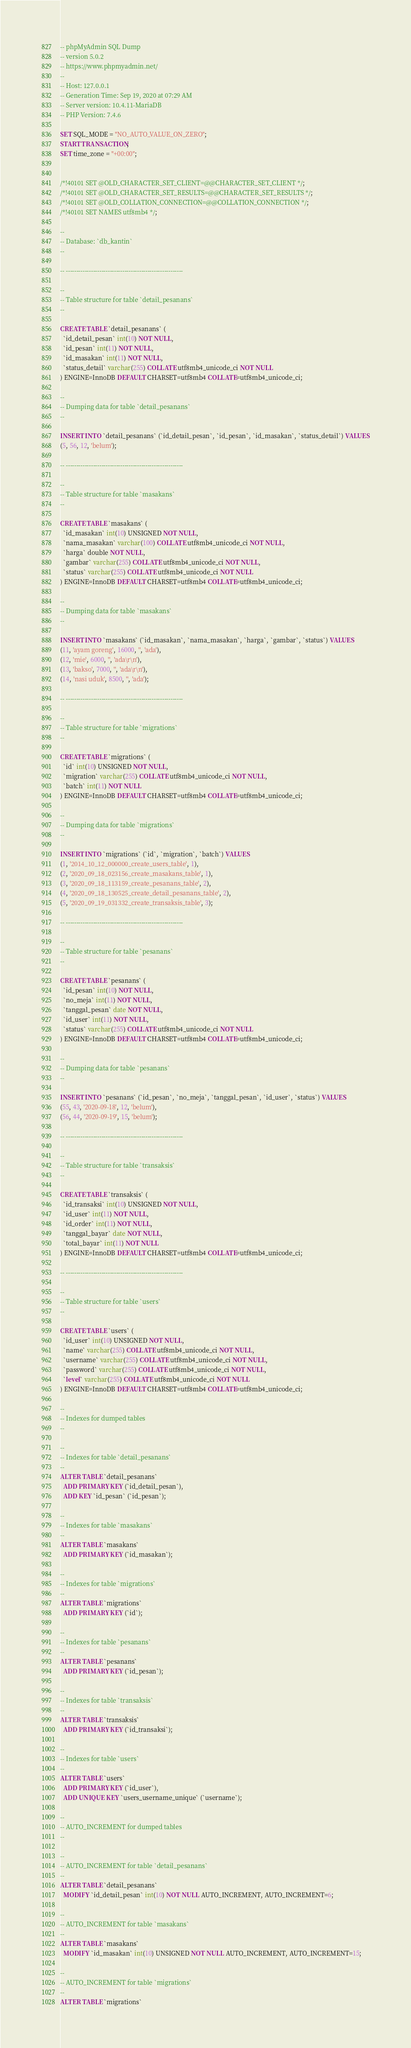Convert code to text. <code><loc_0><loc_0><loc_500><loc_500><_SQL_>-- phpMyAdmin SQL Dump
-- version 5.0.2
-- https://www.phpmyadmin.net/
--
-- Host: 127.0.0.1
-- Generation Time: Sep 19, 2020 at 07:29 AM
-- Server version: 10.4.11-MariaDB
-- PHP Version: 7.4.6

SET SQL_MODE = "NO_AUTO_VALUE_ON_ZERO";
START TRANSACTION;
SET time_zone = "+00:00";


/*!40101 SET @OLD_CHARACTER_SET_CLIENT=@@CHARACTER_SET_CLIENT */;
/*!40101 SET @OLD_CHARACTER_SET_RESULTS=@@CHARACTER_SET_RESULTS */;
/*!40101 SET @OLD_COLLATION_CONNECTION=@@COLLATION_CONNECTION */;
/*!40101 SET NAMES utf8mb4 */;

--
-- Database: `db_kantin`
--

-- --------------------------------------------------------

--
-- Table structure for table `detail_pesanans`
--

CREATE TABLE `detail_pesanans` (
  `id_detail_pesan` int(10) NOT NULL,
  `id_pesan` int(11) NOT NULL,
  `id_masakan` int(11) NOT NULL,
  `status_detail` varchar(255) COLLATE utf8mb4_unicode_ci NOT NULL
) ENGINE=InnoDB DEFAULT CHARSET=utf8mb4 COLLATE=utf8mb4_unicode_ci;

--
-- Dumping data for table `detail_pesanans`
--

INSERT INTO `detail_pesanans` (`id_detail_pesan`, `id_pesan`, `id_masakan`, `status_detail`) VALUES
(5, 56, 12, 'belum');

-- --------------------------------------------------------

--
-- Table structure for table `masakans`
--

CREATE TABLE `masakans` (
  `id_masakan` int(10) UNSIGNED NOT NULL,
  `nama_masakan` varchar(100) COLLATE utf8mb4_unicode_ci NOT NULL,
  `harga` double NOT NULL,
  `gambar` varchar(255) COLLATE utf8mb4_unicode_ci NOT NULL,
  `status` varchar(255) COLLATE utf8mb4_unicode_ci NOT NULL
) ENGINE=InnoDB DEFAULT CHARSET=utf8mb4 COLLATE=utf8mb4_unicode_ci;

--
-- Dumping data for table `masakans`
--

INSERT INTO `masakans` (`id_masakan`, `nama_masakan`, `harga`, `gambar`, `status`) VALUES
(11, 'ayam goreng', 16000, '', 'ada'),
(12, 'mie', 6000, '', 'ada\r\n'),
(13, 'bakso', 7000, '', 'ada\r\n'),
(14, 'nasi uduk', 8500, '', 'ada');

-- --------------------------------------------------------

--
-- Table structure for table `migrations`
--

CREATE TABLE `migrations` (
  `id` int(10) UNSIGNED NOT NULL,
  `migration` varchar(255) COLLATE utf8mb4_unicode_ci NOT NULL,
  `batch` int(11) NOT NULL
) ENGINE=InnoDB DEFAULT CHARSET=utf8mb4 COLLATE=utf8mb4_unicode_ci;

--
-- Dumping data for table `migrations`
--

INSERT INTO `migrations` (`id`, `migration`, `batch`) VALUES
(1, '2014_10_12_000000_create_users_table', 1),
(2, '2020_09_18_023156_create_masakans_table', 1),
(3, '2020_09_18_113159_create_pesanans_table', 2),
(4, '2020_09_18_130525_create_detail_pesanans_table', 2),
(5, '2020_09_19_031332_create_transaksis_table', 3);

-- --------------------------------------------------------

--
-- Table structure for table `pesanans`
--

CREATE TABLE `pesanans` (
  `id_pesan` int(10) NOT NULL,
  `no_meja` int(11) NOT NULL,
  `tanggal_pesan` date NOT NULL,
  `id_user` int(11) NOT NULL,
  `status` varchar(255) COLLATE utf8mb4_unicode_ci NOT NULL
) ENGINE=InnoDB DEFAULT CHARSET=utf8mb4 COLLATE=utf8mb4_unicode_ci;

--
-- Dumping data for table `pesanans`
--

INSERT INTO `pesanans` (`id_pesan`, `no_meja`, `tanggal_pesan`, `id_user`, `status`) VALUES
(55, 43, '2020-09-18', 12, 'belum'),
(56, 44, '2020-09-19', 15, 'belum');

-- --------------------------------------------------------

--
-- Table structure for table `transaksis`
--

CREATE TABLE `transaksis` (
  `id_transaksi` int(10) UNSIGNED NOT NULL,
  `id_user` int(11) NOT NULL,
  `id_order` int(11) NOT NULL,
  `tanggal_bayar` date NOT NULL,
  `total_bayar` int(11) NOT NULL
) ENGINE=InnoDB DEFAULT CHARSET=utf8mb4 COLLATE=utf8mb4_unicode_ci;

-- --------------------------------------------------------

--
-- Table structure for table `users`
--

CREATE TABLE `users` (
  `id_user` int(10) UNSIGNED NOT NULL,
  `name` varchar(255) COLLATE utf8mb4_unicode_ci NOT NULL,
  `username` varchar(255) COLLATE utf8mb4_unicode_ci NOT NULL,
  `password` varchar(255) COLLATE utf8mb4_unicode_ci NOT NULL,
  `level` varchar(255) COLLATE utf8mb4_unicode_ci NOT NULL
) ENGINE=InnoDB DEFAULT CHARSET=utf8mb4 COLLATE=utf8mb4_unicode_ci;

--
-- Indexes for dumped tables
--

--
-- Indexes for table `detail_pesanans`
--
ALTER TABLE `detail_pesanans`
  ADD PRIMARY KEY (`id_detail_pesan`),
  ADD KEY `id_pesan` (`id_pesan`);

--
-- Indexes for table `masakans`
--
ALTER TABLE `masakans`
  ADD PRIMARY KEY (`id_masakan`);

--
-- Indexes for table `migrations`
--
ALTER TABLE `migrations`
  ADD PRIMARY KEY (`id`);

--
-- Indexes for table `pesanans`
--
ALTER TABLE `pesanans`
  ADD PRIMARY KEY (`id_pesan`);

--
-- Indexes for table `transaksis`
--
ALTER TABLE `transaksis`
  ADD PRIMARY KEY (`id_transaksi`);

--
-- Indexes for table `users`
--
ALTER TABLE `users`
  ADD PRIMARY KEY (`id_user`),
  ADD UNIQUE KEY `users_username_unique` (`username`);

--
-- AUTO_INCREMENT for dumped tables
--

--
-- AUTO_INCREMENT for table `detail_pesanans`
--
ALTER TABLE `detail_pesanans`
  MODIFY `id_detail_pesan` int(10) NOT NULL AUTO_INCREMENT, AUTO_INCREMENT=6;

--
-- AUTO_INCREMENT for table `masakans`
--
ALTER TABLE `masakans`
  MODIFY `id_masakan` int(10) UNSIGNED NOT NULL AUTO_INCREMENT, AUTO_INCREMENT=15;

--
-- AUTO_INCREMENT for table `migrations`
--
ALTER TABLE `migrations`</code> 